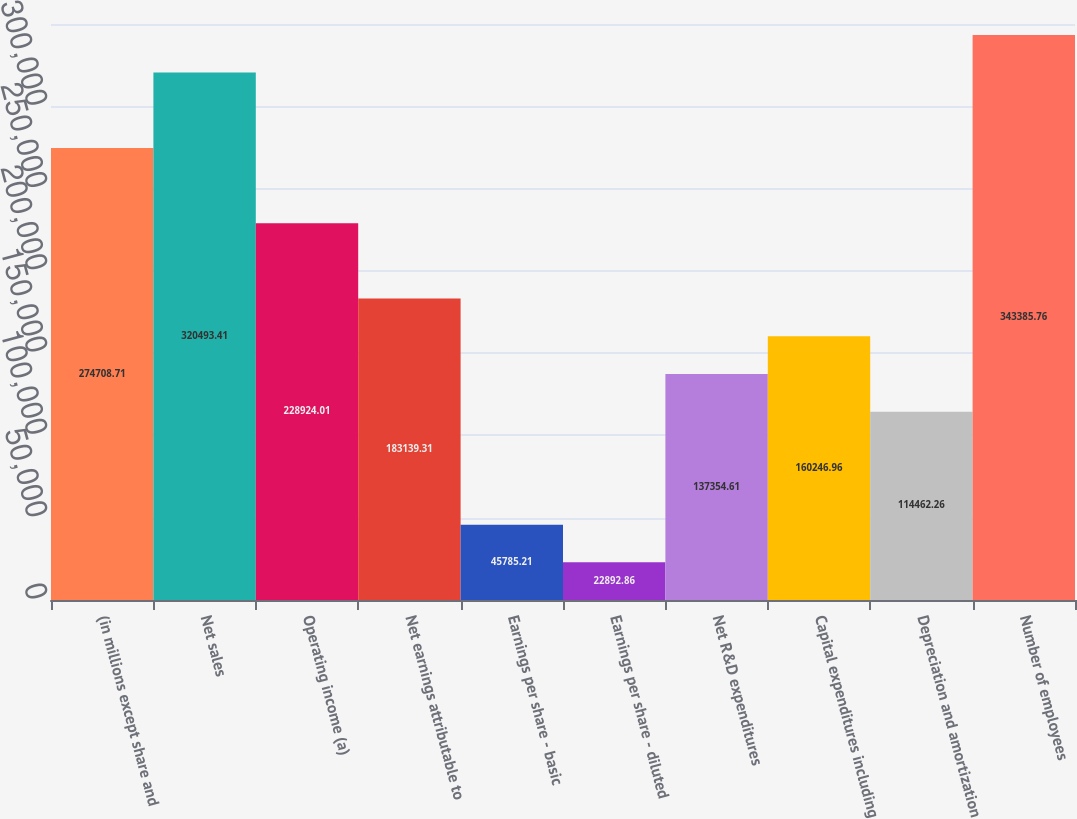Convert chart to OTSL. <chart><loc_0><loc_0><loc_500><loc_500><bar_chart><fcel>(in millions except share and<fcel>Net sales<fcel>Operating income (a)<fcel>Net earnings attributable to<fcel>Earnings per share - basic<fcel>Earnings per share - diluted<fcel>Net R&D expenditures<fcel>Capital expenditures including<fcel>Depreciation and amortization<fcel>Number of employees<nl><fcel>274709<fcel>320493<fcel>228924<fcel>183139<fcel>45785.2<fcel>22892.9<fcel>137355<fcel>160247<fcel>114462<fcel>343386<nl></chart> 